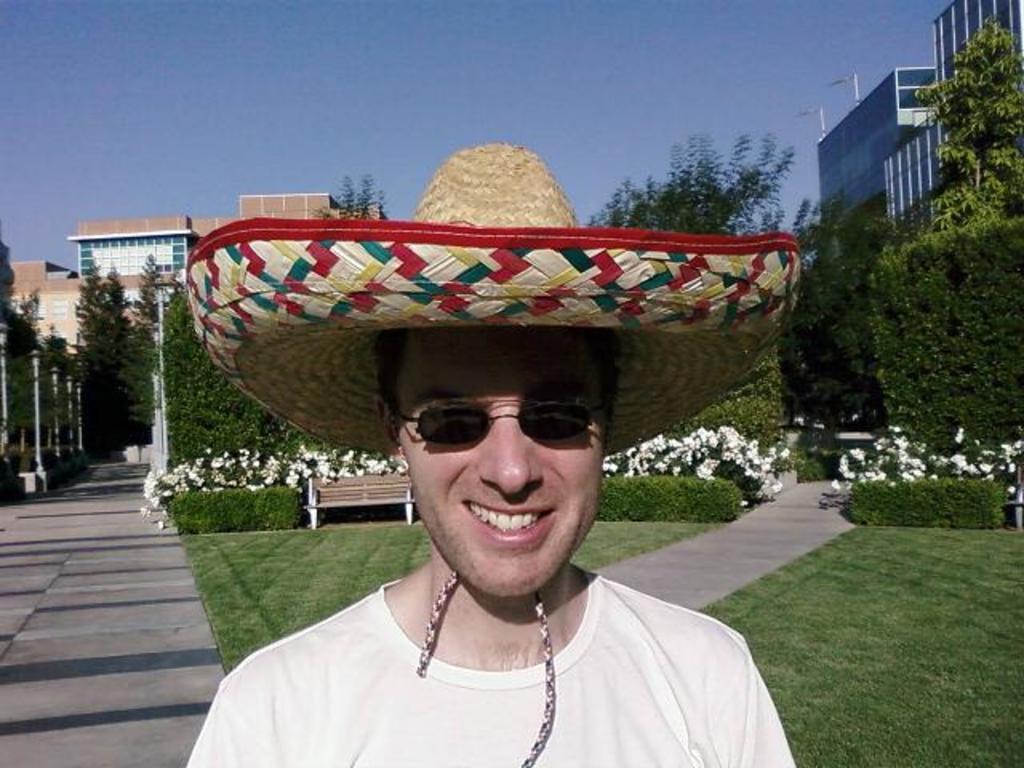Can you describe this image briefly? In this picture we can see a man, he is smiling, he wore spectacles and a cap, in the background we can see a bench, few flowers, trees, poles and buildings. 